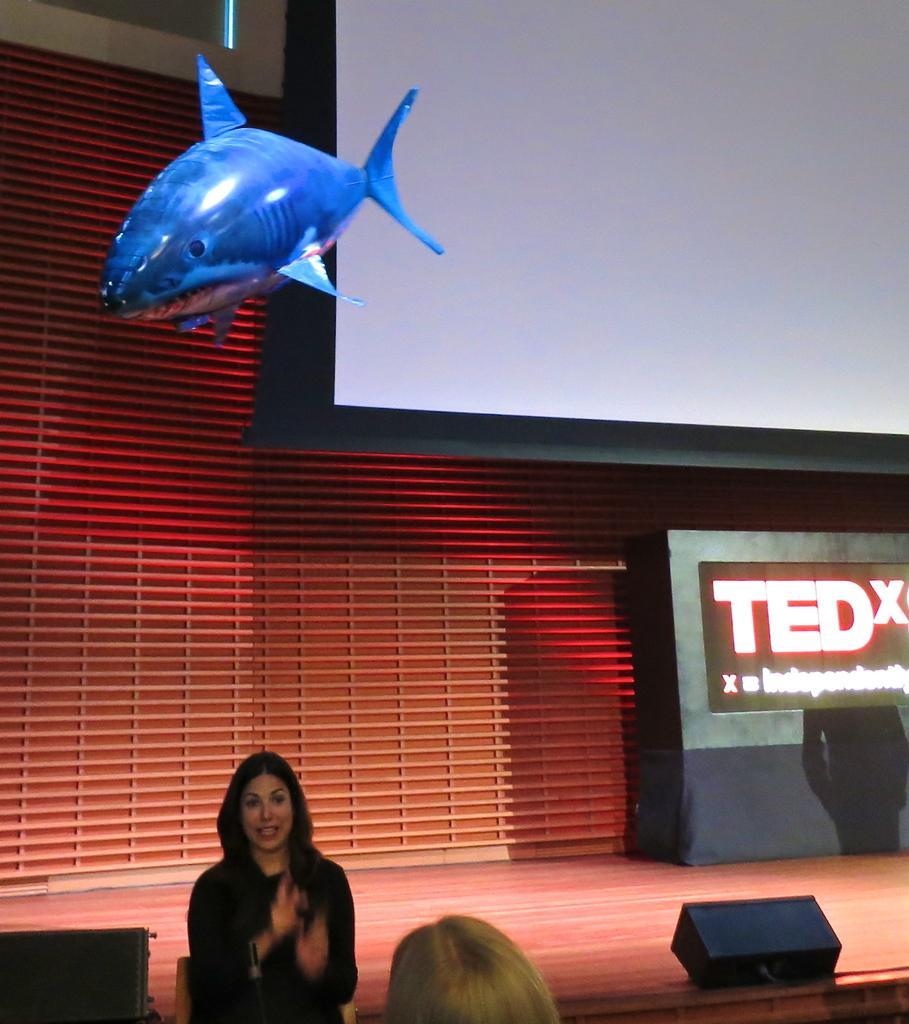Please provide a concise description of this image. In this image there is a person standing , another person, stage, speakers, screens, inflatable shark. 